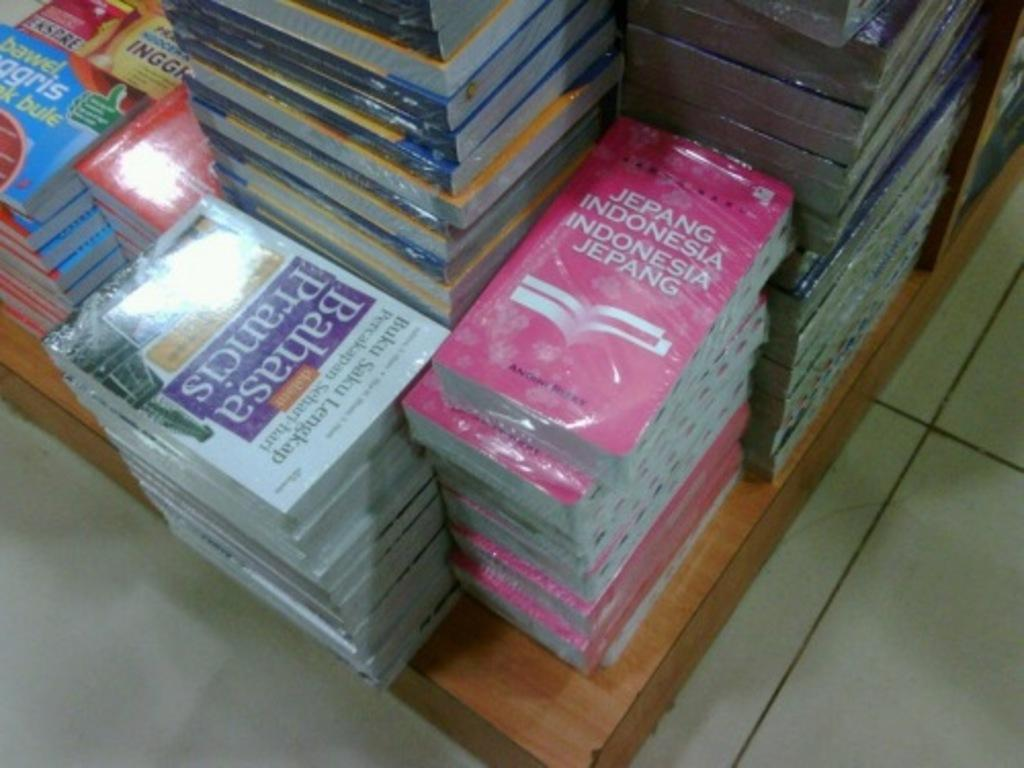<image>
Write a terse but informative summary of the picture. Jepang Indonnesia Indonesia Jepang is a red book. 